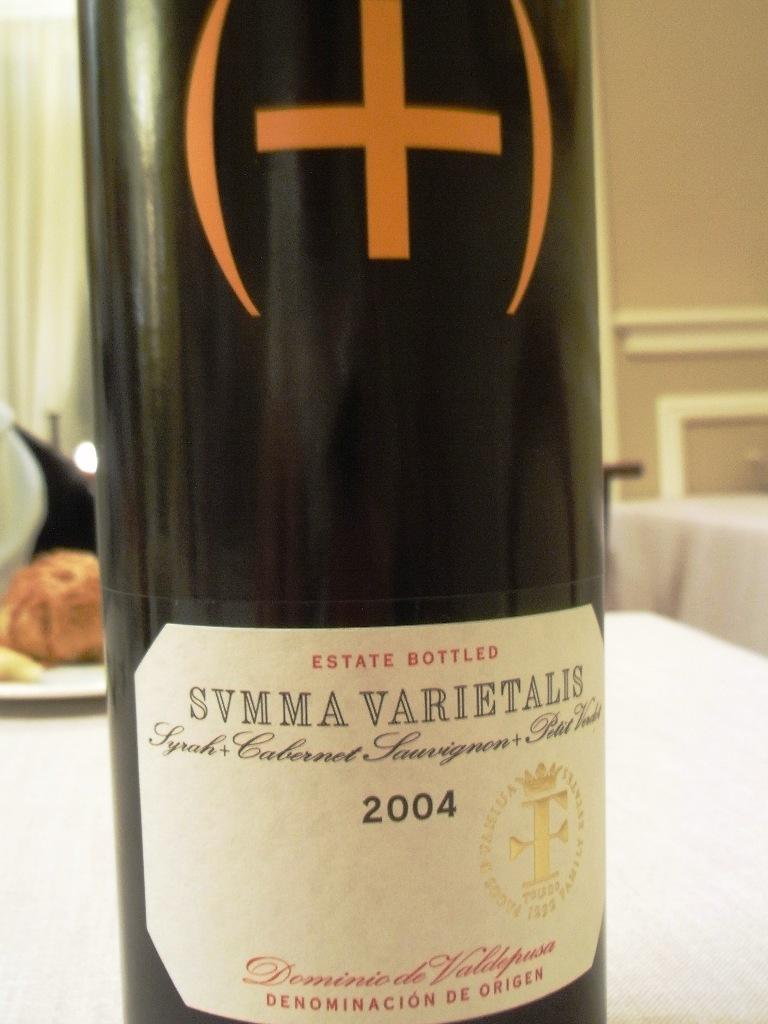<image>
Create a compact narrative representing the image presented. the year 2004 that is on a wine bottle 